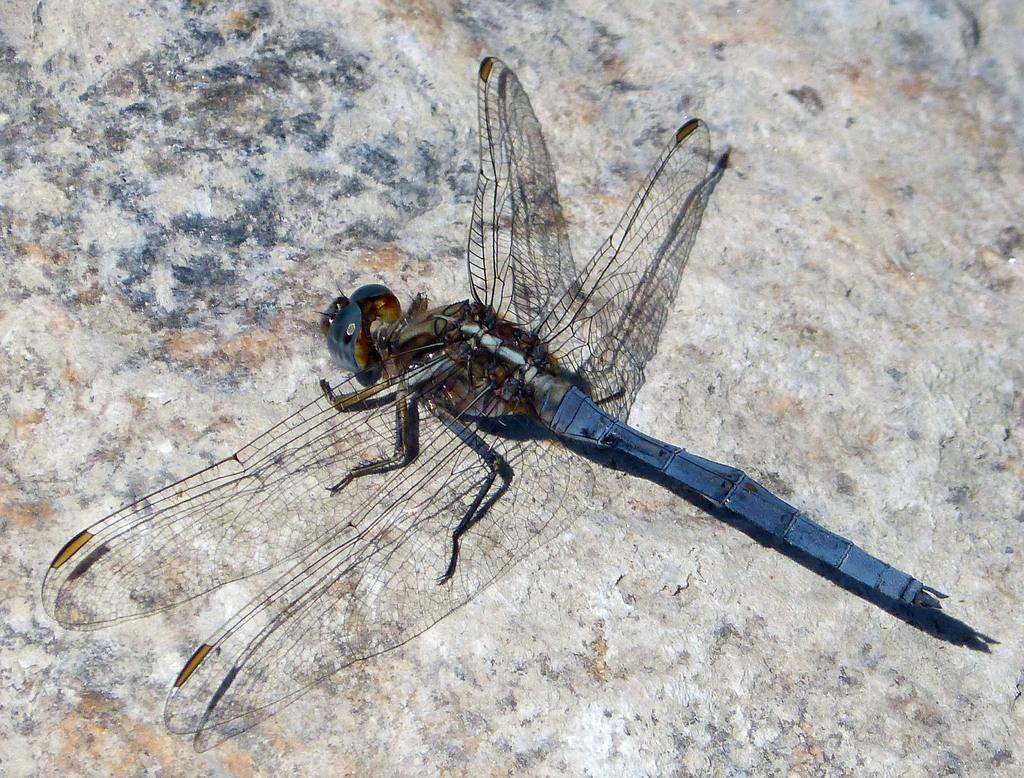What type of creature can be seen in the image? There is an insect in the image. What is the background of the image made of? The background of the image appears to be made of stone. What type of work does the insect do in the image? There is no indication in the image that the insect is performing any work. 